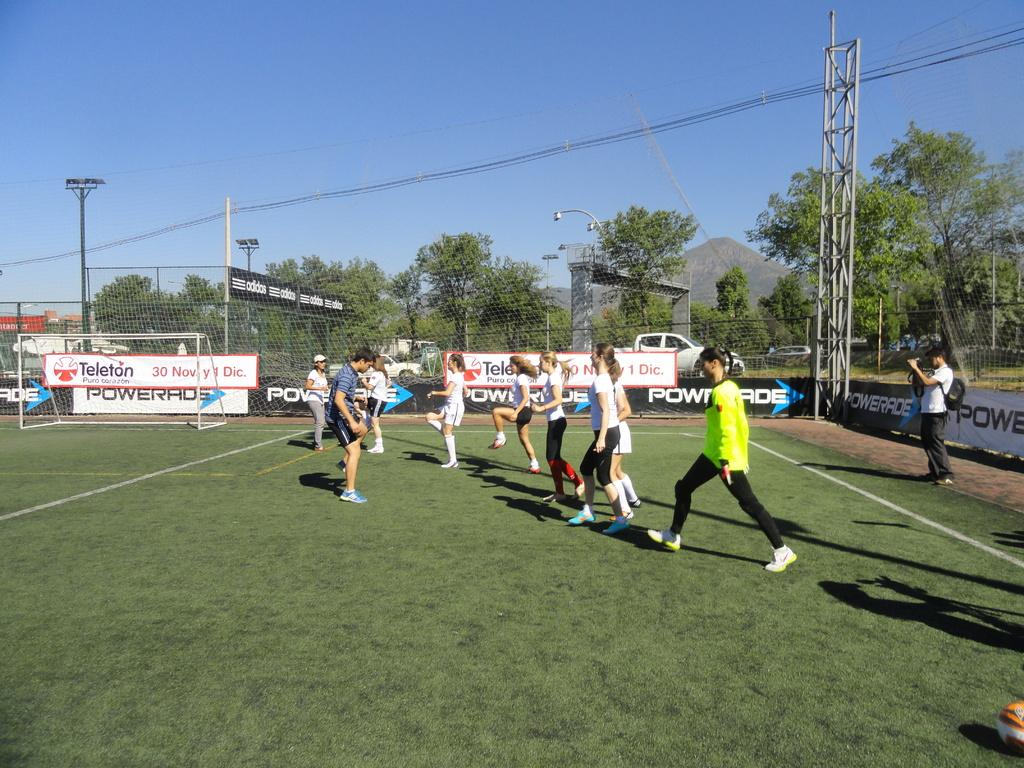Provide a one-sentence caption for the provided image. A banner behind the soccer goal says Teleton and has a November date on it. 